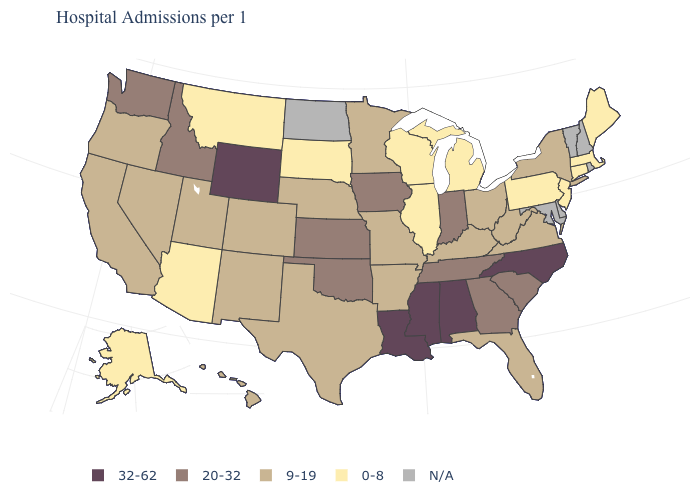What is the lowest value in the USA?
Keep it brief. 0-8. What is the value of Montana?
Keep it brief. 0-8. What is the value of Massachusetts?
Give a very brief answer. 0-8. Name the states that have a value in the range 20-32?
Short answer required. Georgia, Idaho, Indiana, Iowa, Kansas, Oklahoma, South Carolina, Tennessee, Washington. Does the map have missing data?
Answer briefly. Yes. Name the states that have a value in the range 9-19?
Give a very brief answer. Arkansas, California, Colorado, Florida, Hawaii, Kentucky, Minnesota, Missouri, Nebraska, Nevada, New Mexico, New York, Ohio, Oregon, Texas, Utah, Virginia, West Virginia. Name the states that have a value in the range 20-32?
Give a very brief answer. Georgia, Idaho, Indiana, Iowa, Kansas, Oklahoma, South Carolina, Tennessee, Washington. What is the value of Iowa?
Keep it brief. 20-32. Name the states that have a value in the range 20-32?
Give a very brief answer. Georgia, Idaho, Indiana, Iowa, Kansas, Oklahoma, South Carolina, Tennessee, Washington. Name the states that have a value in the range 20-32?
Short answer required. Georgia, Idaho, Indiana, Iowa, Kansas, Oklahoma, South Carolina, Tennessee, Washington. Does the map have missing data?
Be succinct. Yes. Name the states that have a value in the range 20-32?
Concise answer only. Georgia, Idaho, Indiana, Iowa, Kansas, Oklahoma, South Carolina, Tennessee, Washington. Which states have the lowest value in the MidWest?
Quick response, please. Illinois, Michigan, South Dakota, Wisconsin. Name the states that have a value in the range 9-19?
Give a very brief answer. Arkansas, California, Colorado, Florida, Hawaii, Kentucky, Minnesota, Missouri, Nebraska, Nevada, New Mexico, New York, Ohio, Oregon, Texas, Utah, Virginia, West Virginia. 